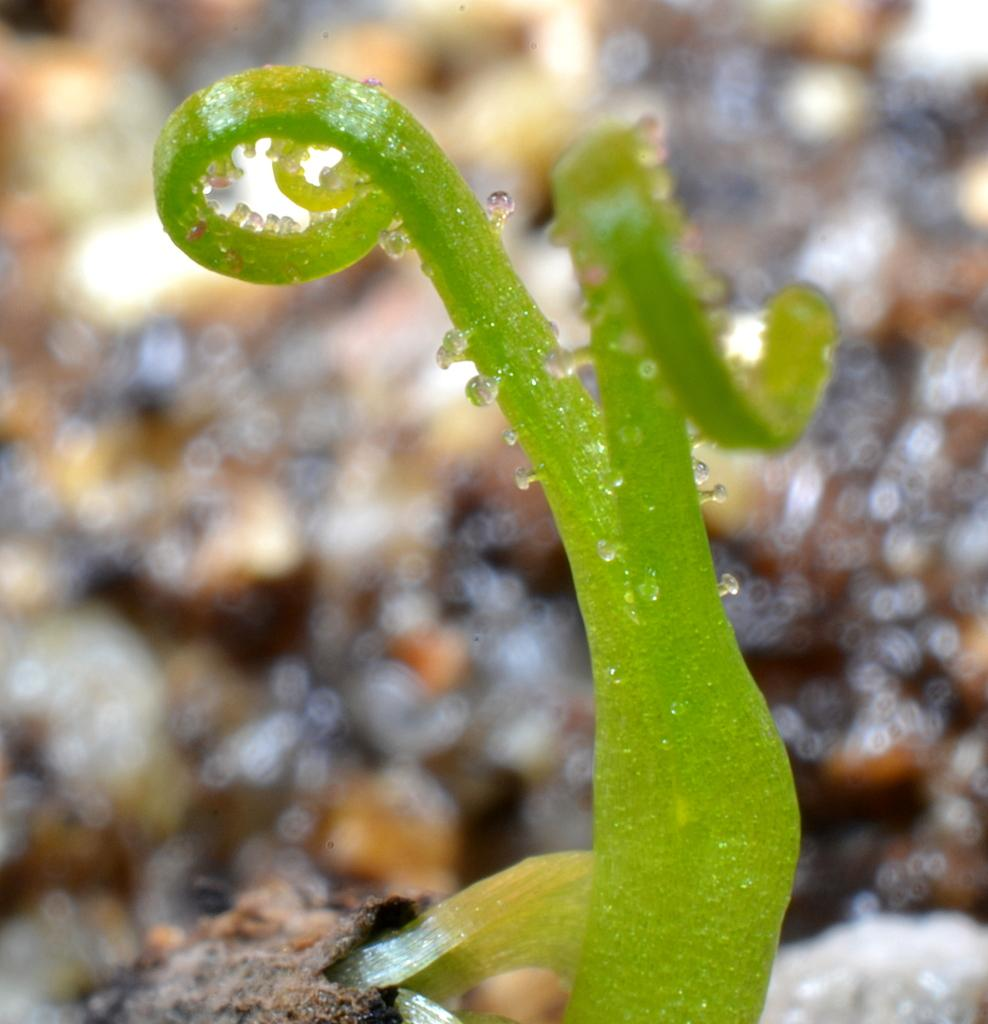What is present in the image? There is a plant in the image. Can you describe the condition of the plant? The plant has water drops on it. What can be observed about the background of the image? The background of the image is blurred. Can you see any ghosts in the image? There are no ghosts present in the image; it features a plant with water drops and a blurred background. What type of stone can be seen in the image? There is no stone present in the image. 